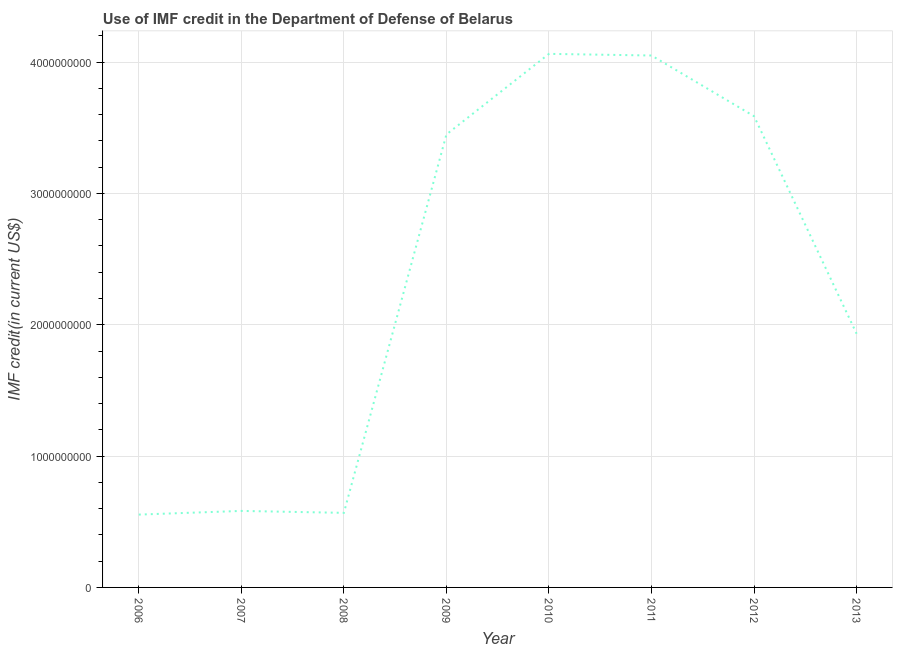What is the use of imf credit in dod in 2012?
Ensure brevity in your answer.  3.59e+09. Across all years, what is the maximum use of imf credit in dod?
Offer a very short reply. 4.06e+09. Across all years, what is the minimum use of imf credit in dod?
Provide a succinct answer. 5.55e+08. In which year was the use of imf credit in dod minimum?
Ensure brevity in your answer.  2006. What is the sum of the use of imf credit in dod?
Make the answer very short. 1.88e+1. What is the difference between the use of imf credit in dod in 2007 and 2013?
Offer a terse response. -1.35e+09. What is the average use of imf credit in dod per year?
Give a very brief answer. 2.35e+09. What is the median use of imf credit in dod?
Offer a very short reply. 2.69e+09. Do a majority of the years between 2010 and 2012 (inclusive) have use of imf credit in dod greater than 2000000000 US$?
Provide a short and direct response. Yes. What is the ratio of the use of imf credit in dod in 2006 to that in 2008?
Provide a short and direct response. 0.98. What is the difference between the highest and the second highest use of imf credit in dod?
Provide a short and direct response. 1.26e+07. Is the sum of the use of imf credit in dod in 2009 and 2012 greater than the maximum use of imf credit in dod across all years?
Give a very brief answer. Yes. What is the difference between the highest and the lowest use of imf credit in dod?
Keep it short and to the point. 3.51e+09. In how many years, is the use of imf credit in dod greater than the average use of imf credit in dod taken over all years?
Ensure brevity in your answer.  4. Are the values on the major ticks of Y-axis written in scientific E-notation?
Keep it short and to the point. No. Does the graph contain any zero values?
Your answer should be very brief. No. What is the title of the graph?
Give a very brief answer. Use of IMF credit in the Department of Defense of Belarus. What is the label or title of the Y-axis?
Ensure brevity in your answer.  IMF credit(in current US$). What is the IMF credit(in current US$) of 2006?
Provide a succinct answer. 5.55e+08. What is the IMF credit(in current US$) in 2007?
Provide a short and direct response. 5.83e+08. What is the IMF credit(in current US$) of 2008?
Provide a succinct answer. 5.68e+08. What is the IMF credit(in current US$) in 2009?
Provide a short and direct response. 3.45e+09. What is the IMF credit(in current US$) of 2010?
Your answer should be compact. 4.06e+09. What is the IMF credit(in current US$) in 2011?
Keep it short and to the point. 4.05e+09. What is the IMF credit(in current US$) in 2012?
Your answer should be very brief. 3.59e+09. What is the IMF credit(in current US$) in 2013?
Offer a terse response. 1.93e+09. What is the difference between the IMF credit(in current US$) in 2006 and 2007?
Give a very brief answer. -2.80e+07. What is the difference between the IMF credit(in current US$) in 2006 and 2008?
Your answer should be compact. -1.32e+07. What is the difference between the IMF credit(in current US$) in 2006 and 2009?
Your answer should be compact. -2.89e+09. What is the difference between the IMF credit(in current US$) in 2006 and 2010?
Your response must be concise. -3.51e+09. What is the difference between the IMF credit(in current US$) in 2006 and 2011?
Provide a short and direct response. -3.50e+09. What is the difference between the IMF credit(in current US$) in 2006 and 2012?
Ensure brevity in your answer.  -3.03e+09. What is the difference between the IMF credit(in current US$) in 2006 and 2013?
Your response must be concise. -1.38e+09. What is the difference between the IMF credit(in current US$) in 2007 and 2008?
Give a very brief answer. 1.47e+07. What is the difference between the IMF credit(in current US$) in 2007 and 2009?
Your answer should be very brief. -2.87e+09. What is the difference between the IMF credit(in current US$) in 2007 and 2010?
Your response must be concise. -3.48e+09. What is the difference between the IMF credit(in current US$) in 2007 and 2011?
Ensure brevity in your answer.  -3.47e+09. What is the difference between the IMF credit(in current US$) in 2007 and 2012?
Your answer should be compact. -3.01e+09. What is the difference between the IMF credit(in current US$) in 2007 and 2013?
Your response must be concise. -1.35e+09. What is the difference between the IMF credit(in current US$) in 2008 and 2009?
Give a very brief answer. -2.88e+09. What is the difference between the IMF credit(in current US$) in 2008 and 2010?
Offer a terse response. -3.50e+09. What is the difference between the IMF credit(in current US$) in 2008 and 2011?
Give a very brief answer. -3.48e+09. What is the difference between the IMF credit(in current US$) in 2008 and 2012?
Your answer should be compact. -3.02e+09. What is the difference between the IMF credit(in current US$) in 2008 and 2013?
Offer a very short reply. -1.36e+09. What is the difference between the IMF credit(in current US$) in 2009 and 2010?
Keep it short and to the point. -6.14e+08. What is the difference between the IMF credit(in current US$) in 2009 and 2011?
Provide a succinct answer. -6.01e+08. What is the difference between the IMF credit(in current US$) in 2009 and 2012?
Your answer should be very brief. -1.39e+08. What is the difference between the IMF credit(in current US$) in 2009 and 2013?
Give a very brief answer. 1.52e+09. What is the difference between the IMF credit(in current US$) in 2010 and 2011?
Your answer should be very brief. 1.26e+07. What is the difference between the IMF credit(in current US$) in 2010 and 2012?
Your answer should be compact. 4.75e+08. What is the difference between the IMF credit(in current US$) in 2010 and 2013?
Your answer should be compact. 2.13e+09. What is the difference between the IMF credit(in current US$) in 2011 and 2012?
Your response must be concise. 4.62e+08. What is the difference between the IMF credit(in current US$) in 2011 and 2013?
Ensure brevity in your answer.  2.12e+09. What is the difference between the IMF credit(in current US$) in 2012 and 2013?
Provide a short and direct response. 1.66e+09. What is the ratio of the IMF credit(in current US$) in 2006 to that in 2009?
Provide a short and direct response. 0.16. What is the ratio of the IMF credit(in current US$) in 2006 to that in 2010?
Ensure brevity in your answer.  0.14. What is the ratio of the IMF credit(in current US$) in 2006 to that in 2011?
Your answer should be very brief. 0.14. What is the ratio of the IMF credit(in current US$) in 2006 to that in 2012?
Give a very brief answer. 0.15. What is the ratio of the IMF credit(in current US$) in 2006 to that in 2013?
Your response must be concise. 0.29. What is the ratio of the IMF credit(in current US$) in 2007 to that in 2008?
Your answer should be compact. 1.03. What is the ratio of the IMF credit(in current US$) in 2007 to that in 2009?
Your answer should be very brief. 0.17. What is the ratio of the IMF credit(in current US$) in 2007 to that in 2010?
Ensure brevity in your answer.  0.14. What is the ratio of the IMF credit(in current US$) in 2007 to that in 2011?
Make the answer very short. 0.14. What is the ratio of the IMF credit(in current US$) in 2007 to that in 2012?
Your response must be concise. 0.16. What is the ratio of the IMF credit(in current US$) in 2007 to that in 2013?
Ensure brevity in your answer.  0.3. What is the ratio of the IMF credit(in current US$) in 2008 to that in 2009?
Offer a very short reply. 0.17. What is the ratio of the IMF credit(in current US$) in 2008 to that in 2010?
Keep it short and to the point. 0.14. What is the ratio of the IMF credit(in current US$) in 2008 to that in 2011?
Provide a short and direct response. 0.14. What is the ratio of the IMF credit(in current US$) in 2008 to that in 2012?
Your response must be concise. 0.16. What is the ratio of the IMF credit(in current US$) in 2008 to that in 2013?
Make the answer very short. 0.29. What is the ratio of the IMF credit(in current US$) in 2009 to that in 2010?
Make the answer very short. 0.85. What is the ratio of the IMF credit(in current US$) in 2009 to that in 2011?
Offer a very short reply. 0.85. What is the ratio of the IMF credit(in current US$) in 2009 to that in 2013?
Your answer should be compact. 1.78. What is the ratio of the IMF credit(in current US$) in 2010 to that in 2011?
Give a very brief answer. 1. What is the ratio of the IMF credit(in current US$) in 2010 to that in 2012?
Keep it short and to the point. 1.13. What is the ratio of the IMF credit(in current US$) in 2010 to that in 2013?
Your answer should be compact. 2.1. What is the ratio of the IMF credit(in current US$) in 2011 to that in 2012?
Your response must be concise. 1.13. What is the ratio of the IMF credit(in current US$) in 2011 to that in 2013?
Provide a short and direct response. 2.1. What is the ratio of the IMF credit(in current US$) in 2012 to that in 2013?
Make the answer very short. 1.86. 